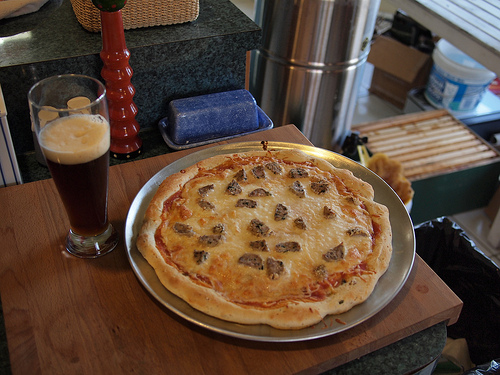<image>
Is there a pizza on the table? Yes. Looking at the image, I can see the pizza is positioned on top of the table, with the table providing support. Is the cup on the box? No. The cup is not positioned on the box. They may be near each other, but the cup is not supported by or resting on top of the box. 